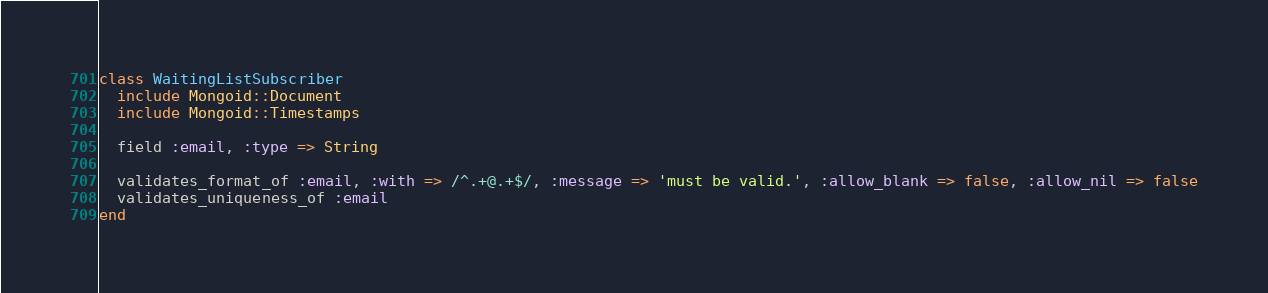Convert code to text. <code><loc_0><loc_0><loc_500><loc_500><_Ruby_>class WaitingListSubscriber
  include Mongoid::Document
  include Mongoid::Timestamps
  
  field :email, :type => String
  
  validates_format_of :email, :with => /^.+@.+$/, :message => 'must be valid.', :allow_blank => false, :allow_nil => false
  validates_uniqueness_of :email
end
</code> 